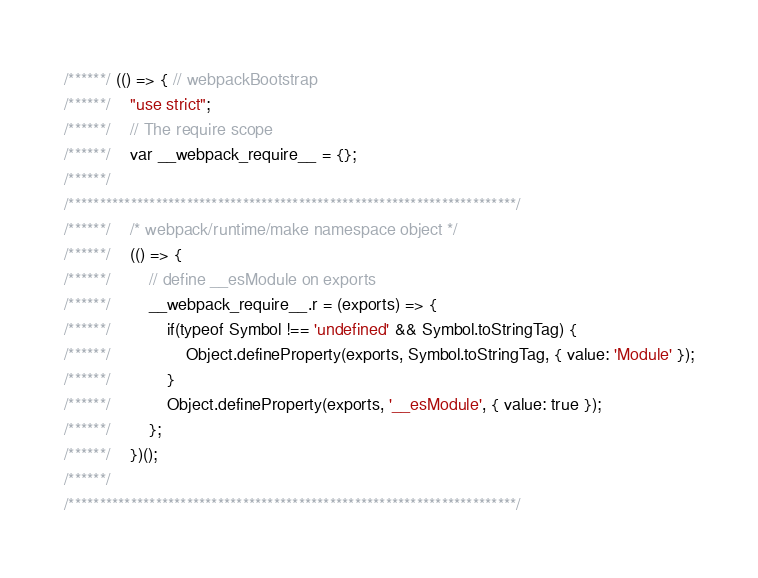<code> <loc_0><loc_0><loc_500><loc_500><_JavaScript_>/******/ (() => { // webpackBootstrap
/******/ 	"use strict";
/******/ 	// The require scope
/******/ 	var __webpack_require__ = {};
/******/ 	
/************************************************************************/
/******/ 	/* webpack/runtime/make namespace object */
/******/ 	(() => {
/******/ 		// define __esModule on exports
/******/ 		__webpack_require__.r = (exports) => {
/******/ 			if(typeof Symbol !== 'undefined' && Symbol.toStringTag) {
/******/ 				Object.defineProperty(exports, Symbol.toStringTag, { value: 'Module' });
/******/ 			}
/******/ 			Object.defineProperty(exports, '__esModule', { value: true });
/******/ 		};
/******/ 	})();
/******/ 	
/************************************************************************/</code> 